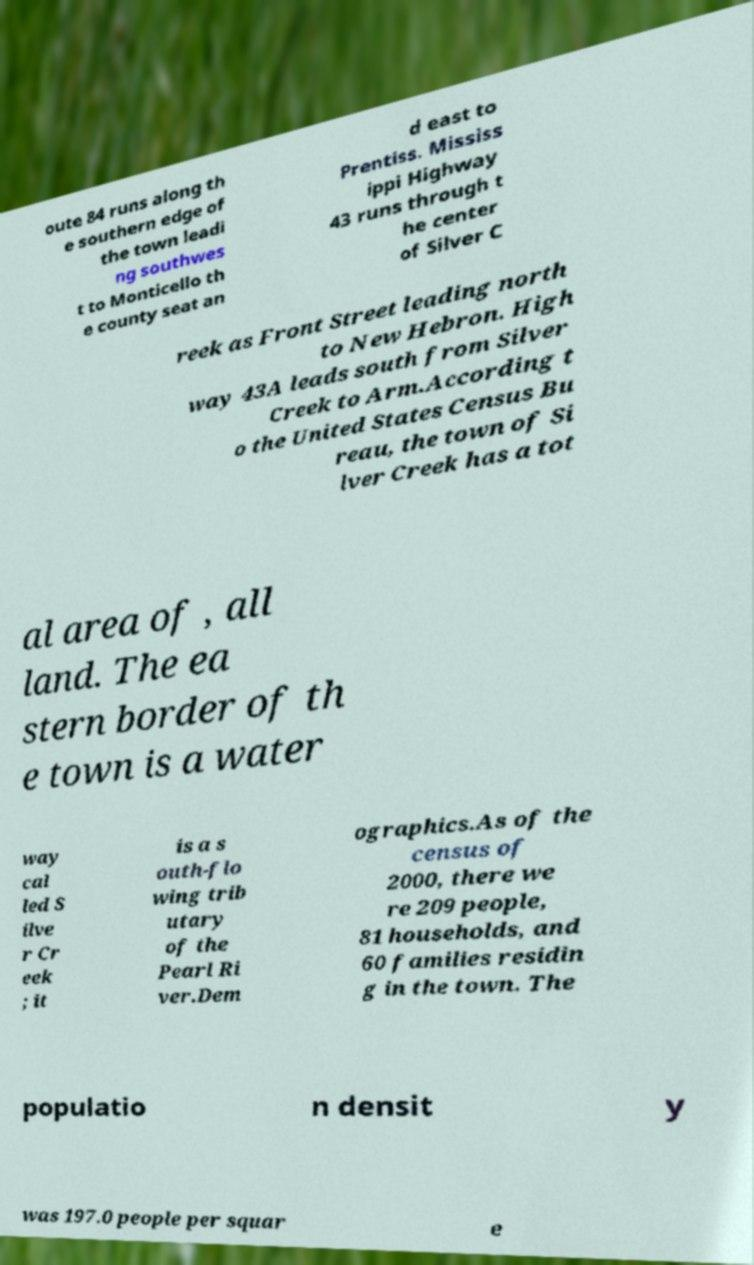I need the written content from this picture converted into text. Can you do that? oute 84 runs along th e southern edge of the town leadi ng southwes t to Monticello th e county seat an d east to Prentiss. Mississ ippi Highway 43 runs through t he center of Silver C reek as Front Street leading north to New Hebron. High way 43A leads south from Silver Creek to Arm.According t o the United States Census Bu reau, the town of Si lver Creek has a tot al area of , all land. The ea stern border of th e town is a water way cal led S ilve r Cr eek ; it is a s outh-flo wing trib utary of the Pearl Ri ver.Dem ographics.As of the census of 2000, there we re 209 people, 81 households, and 60 families residin g in the town. The populatio n densit y was 197.0 people per squar e 